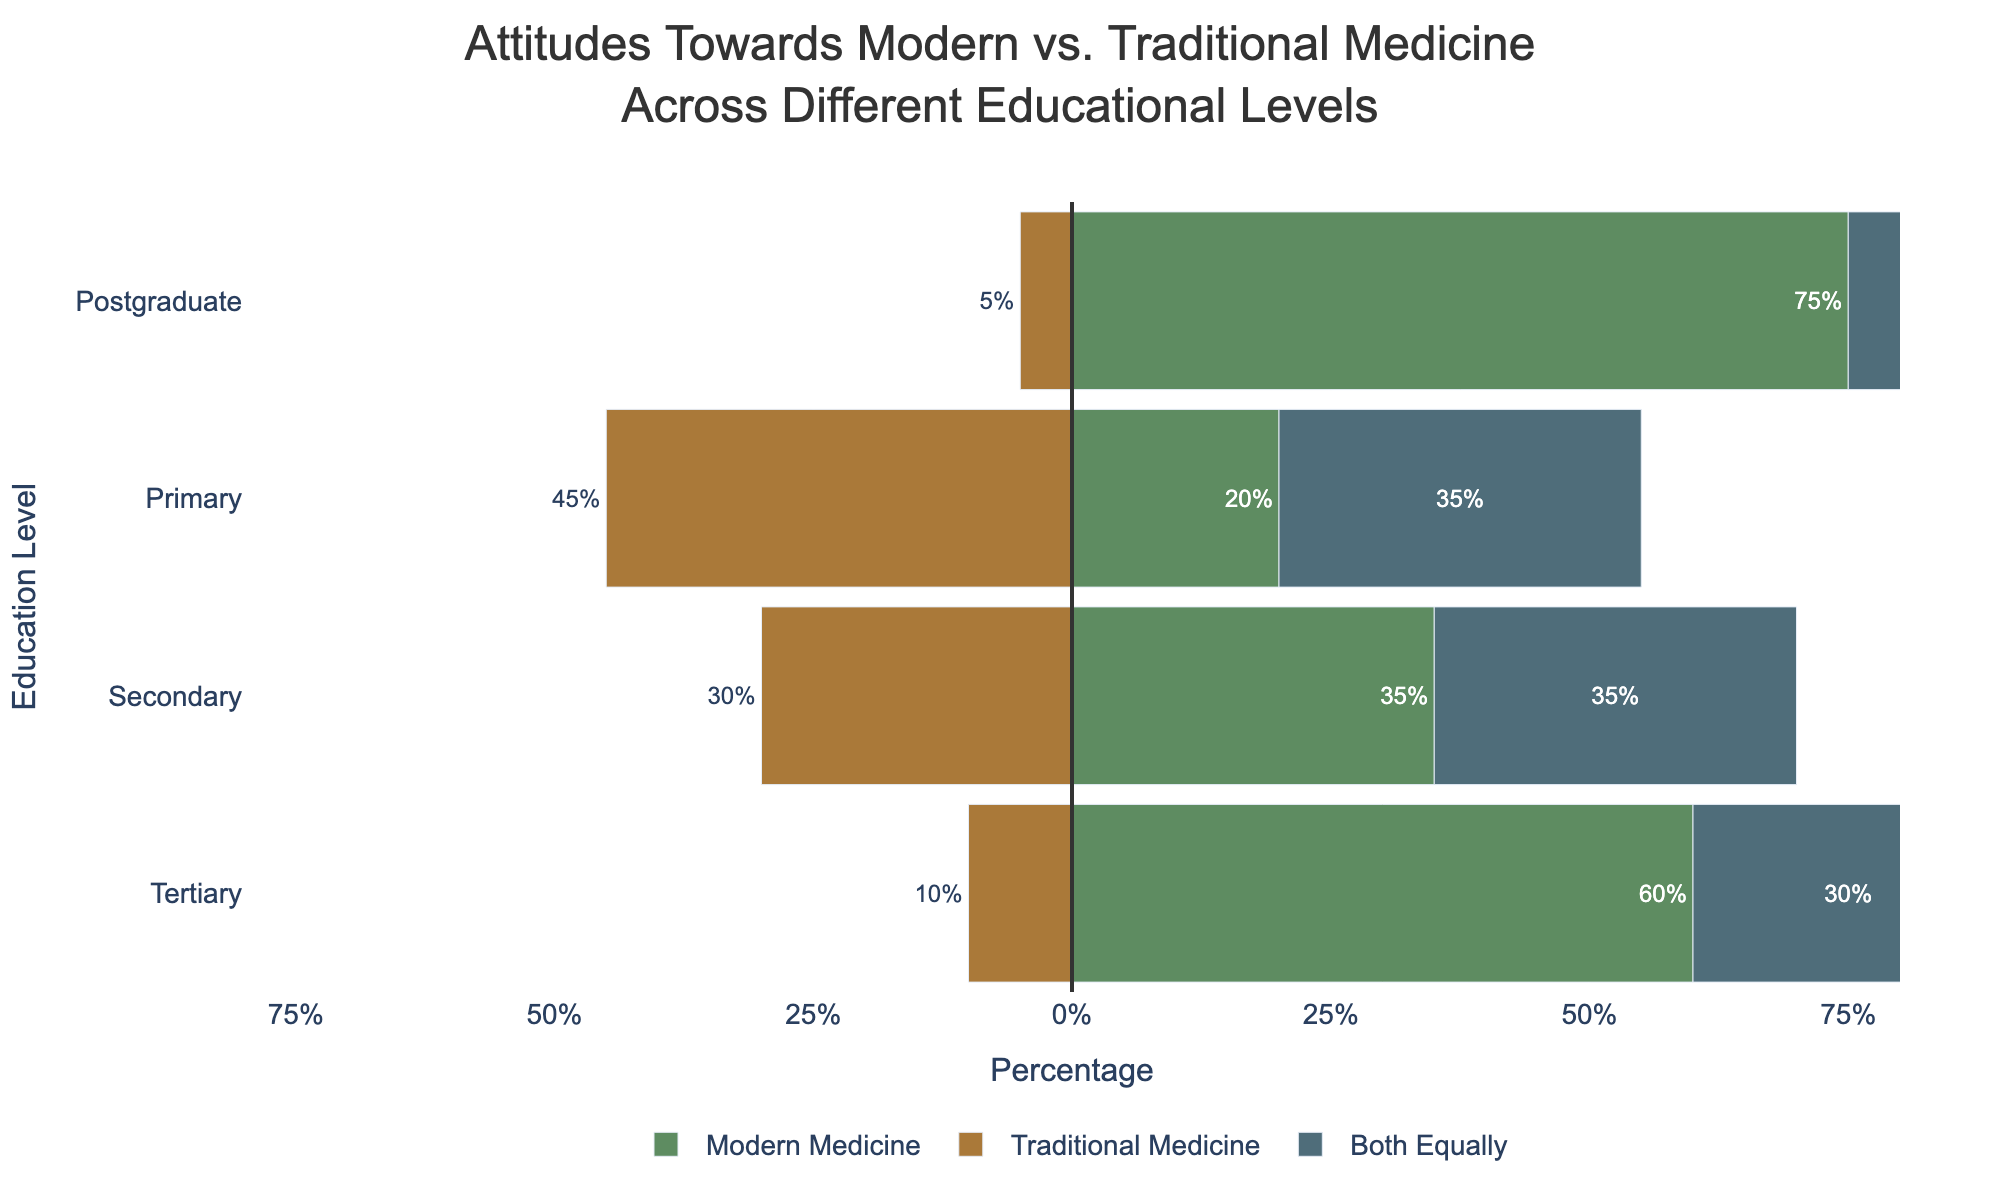Which education level prefers modern medicine the most? Examine the bar lengths for each education level under "Modern Medicine". The longest bar is for Postgraduate education.
Answer: Postgraduate Which education level has the highest percentage of people preferring traditional medicine? Look at the bar lengths for each education level under "Traditional Medicine". The longest bar is for Primary education.
Answer: Primary What's the total percentage of people with Primary education who prefer either traditional medicine or both equally? Add the percentages of Traditional Medicine and Both Equally for Primary education: 45% + 35% = 80%.
Answer: 80% Compare the percentage of people with Secondary education who prefer modern medicine to those who prefer both equally. Which is higher? Compare the lengths of the bars for "Modern Medicine" and "Both Equally". Both bars are marked with 35%, making them equal.
Answer: Both are equal Is the percentage of people with Tertiary education who prefer both equally greater than those who prefer traditional medicine? Compare the lengths of the bars for Tertiary education under "Both Equally" (30%) and "Traditional Medicine" (10%). The bar for Both Equally is longer.
Answer: Yes What's the difference in the percentage of people preferring modern medicine between those with Secondary education and those with Tertiary education? Subtract the percentage of Secondary education from Tertiary education for Modern Medicine: 60% - 35% = 25%.
Answer: 25% What's the sum of the percentages for Postgraduate education preferences? Add all the percentages for preferences in Postgraduate education: 75% (Modern Medicine) + 5% (Traditional Medicine) + 20% (Both Equally) = 100%.
Answer: 100% Which preference category has the shortest bar for Postgraduate education? Compare the lengths of all bars for Postgraduate education. The shortest bar belongs to "Traditional Medicine" (5%).
Answer: Traditional Medicine Is there an education level where the percentages of people preferring modern medicine and traditional medicine are the same? Check if the bar lengths for Modern and Traditional Medicine are equal for any education level. No bars for Modern Medicine and Traditional Medicine are equal across the levels.
Answer: No Between Primary and Secondary education, which level has a higher percentage of people preferring both equally? Compare the "Both Equally" bar lengths for Primary and Secondary education. Both are at 35%, making them equal.
Answer: Both are equal 